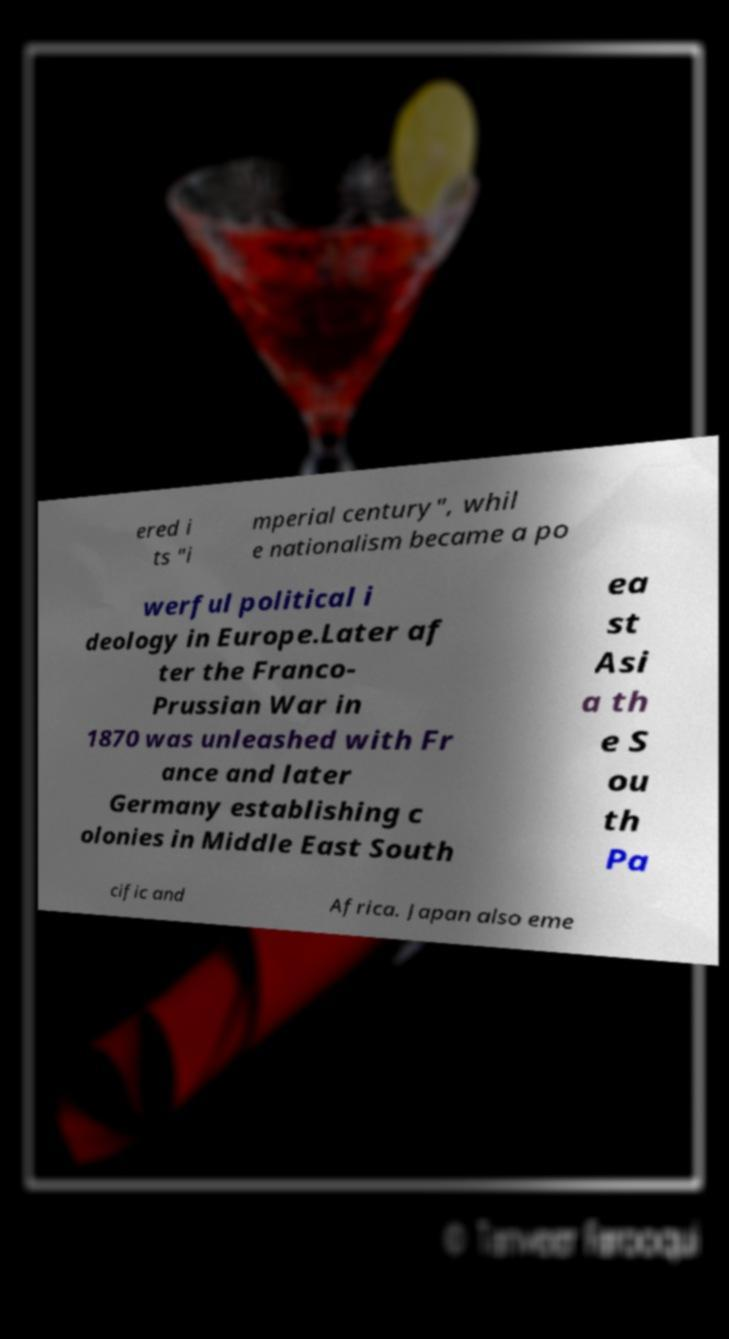I need the written content from this picture converted into text. Can you do that? ered i ts "i mperial century", whil e nationalism became a po werful political i deology in Europe.Later af ter the Franco- Prussian War in 1870 was unleashed with Fr ance and later Germany establishing c olonies in Middle East South ea st Asi a th e S ou th Pa cific and Africa. Japan also eme 